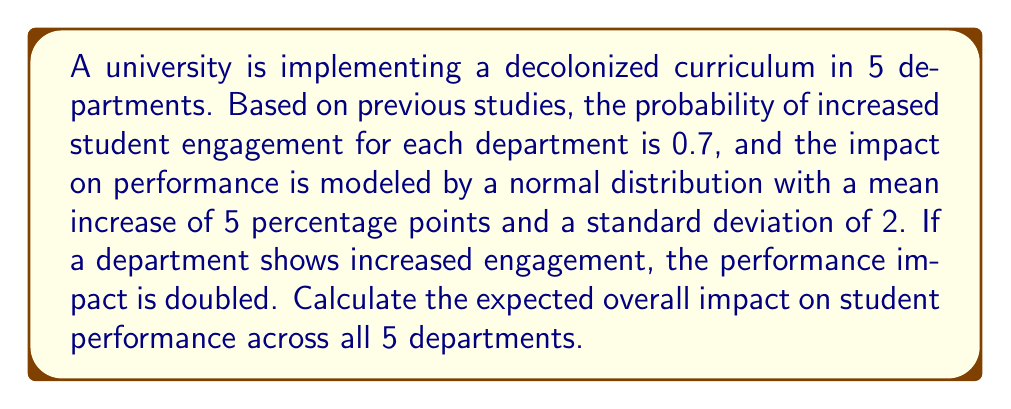Could you help me with this problem? Let's approach this step-by-step:

1) First, we need to calculate the expected impact for a single department:

   a) Probability of increased engagement: $p = 0.7$
   b) Impact if no increased engagement: $\mu_1 = 5$ percentage points
   c) Impact if increased engagement: $\mu_2 = 2\mu_1 = 10$ percentage points

2) The expected impact for a single department is:

   $E(\text{impact}) = p\mu_2 + (1-p)\mu_1$
   $= 0.7 \cdot 10 + 0.3 \cdot 5$
   $= 7 + 1.5 = 8.5$ percentage points

3) Since there are 5 departments, and each department's impact is independent, we multiply the single department impact by 5:

   $E(\text{total impact}) = 5 \cdot 8.5 = 42.5$ percentage points

4) To calculate the standard deviation, we need to use the law of total variance:

   $\text{Var}(\text{impact}) = E[\text{Var}(X|Y)] + \text{Var}(E[X|Y])$

   Where $X$ is the impact and $Y$ is whether engagement increased.

5) $E[\text{Var}(X|Y)] = p\sigma^2 + (1-p)\sigma^2 = \sigma^2 = 4$

6) $\text{Var}(E[X|Y]) = p(1-p)(\mu_2 - \mu_1)^2 = 0.7 \cdot 0.3 \cdot 5^2 = 5.25$

7) $\text{Var}(\text{impact}) = 4 + 5.25 = 9.25$

8) For 5 independent departments:

   $\text{Var}(\text{total impact}) = 5 \cdot 9.25 = 46.25$

9) The standard deviation of the total impact:

   $\sigma_{\text{total}} = \sqrt{46.25} \approx 6.8$ percentage points

Therefore, the expected overall impact on student performance across all 5 departments is $42.5$ percentage points, with a standard deviation of approximately $6.8$ percentage points.
Answer: $42.5 \pm 6.8$ percentage points 